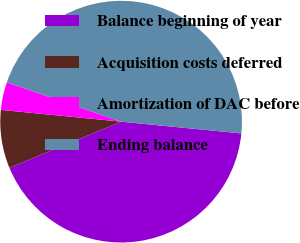Convert chart to OTSL. <chart><loc_0><loc_0><loc_500><loc_500><pie_chart><fcel>Balance beginning of year<fcel>Acquisition costs deferred<fcel>Amortization of DAC before<fcel>Ending balance<nl><fcel>42.21%<fcel>7.79%<fcel>3.72%<fcel>46.28%<nl></chart> 